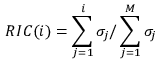Convert formula to latex. <formula><loc_0><loc_0><loc_500><loc_500>R I C ( i ) = \sum _ { j = 1 } ^ { i } \sigma _ { j } / \sum _ { j = 1 } ^ { M } \sigma _ { j }</formula> 